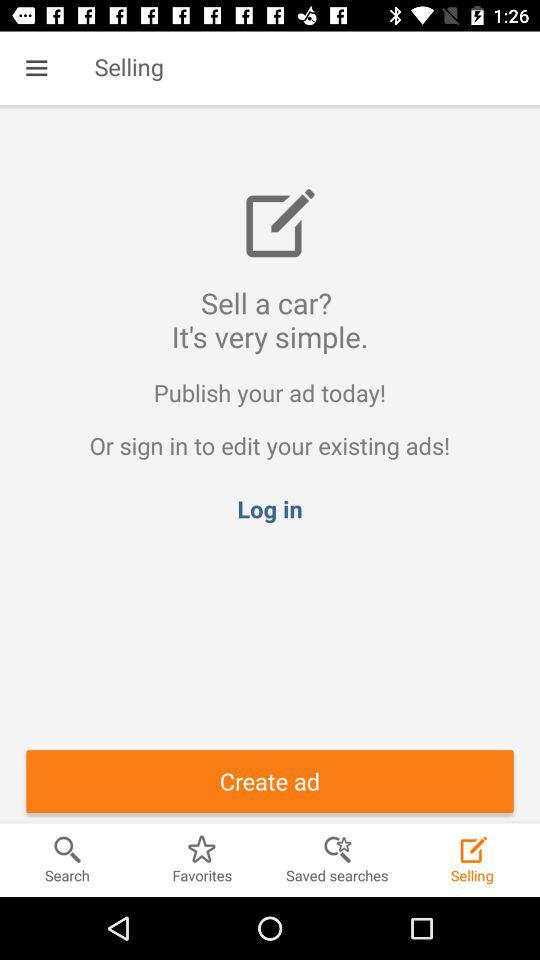What are the names of the ads listed?
When the provided information is insufficient, respond with <no answer>. <no answer> 